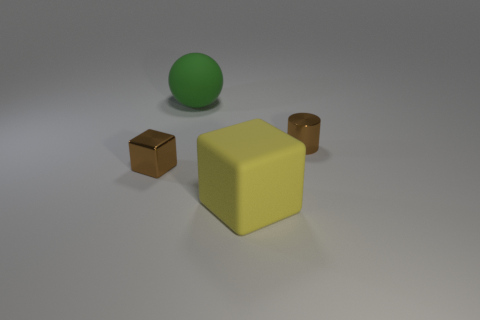Subtract 0 gray cylinders. How many objects are left? 4 Subtract all balls. How many objects are left? 3 Subtract 1 balls. How many balls are left? 0 Subtract all red cubes. Subtract all gray balls. How many cubes are left? 2 Subtract all gray spheres. How many yellow blocks are left? 1 Subtract all small purple cubes. Subtract all matte blocks. How many objects are left? 3 Add 3 big yellow rubber things. How many big yellow rubber things are left? 4 Add 3 big green rubber objects. How many big green rubber objects exist? 4 Add 2 brown metallic cubes. How many objects exist? 6 